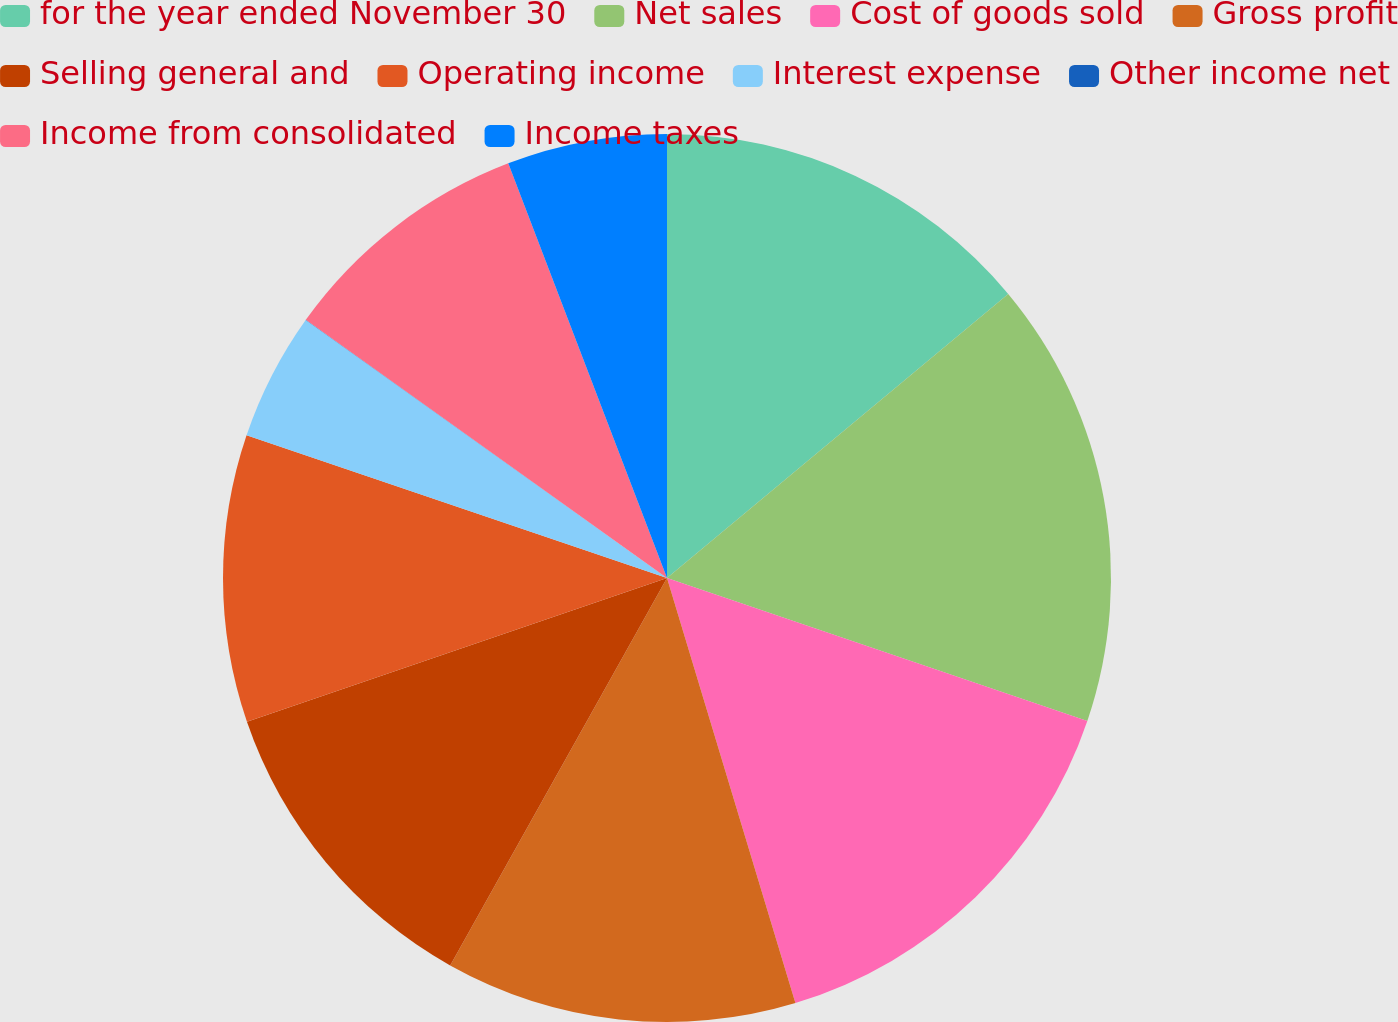Convert chart. <chart><loc_0><loc_0><loc_500><loc_500><pie_chart><fcel>for the year ended November 30<fcel>Net sales<fcel>Cost of goods sold<fcel>Gross profit<fcel>Selling general and<fcel>Operating income<fcel>Interest expense<fcel>Other income net<fcel>Income from consolidated<fcel>Income taxes<nl><fcel>13.95%<fcel>16.27%<fcel>15.11%<fcel>12.79%<fcel>11.63%<fcel>10.46%<fcel>4.66%<fcel>0.01%<fcel>9.3%<fcel>5.82%<nl></chart> 